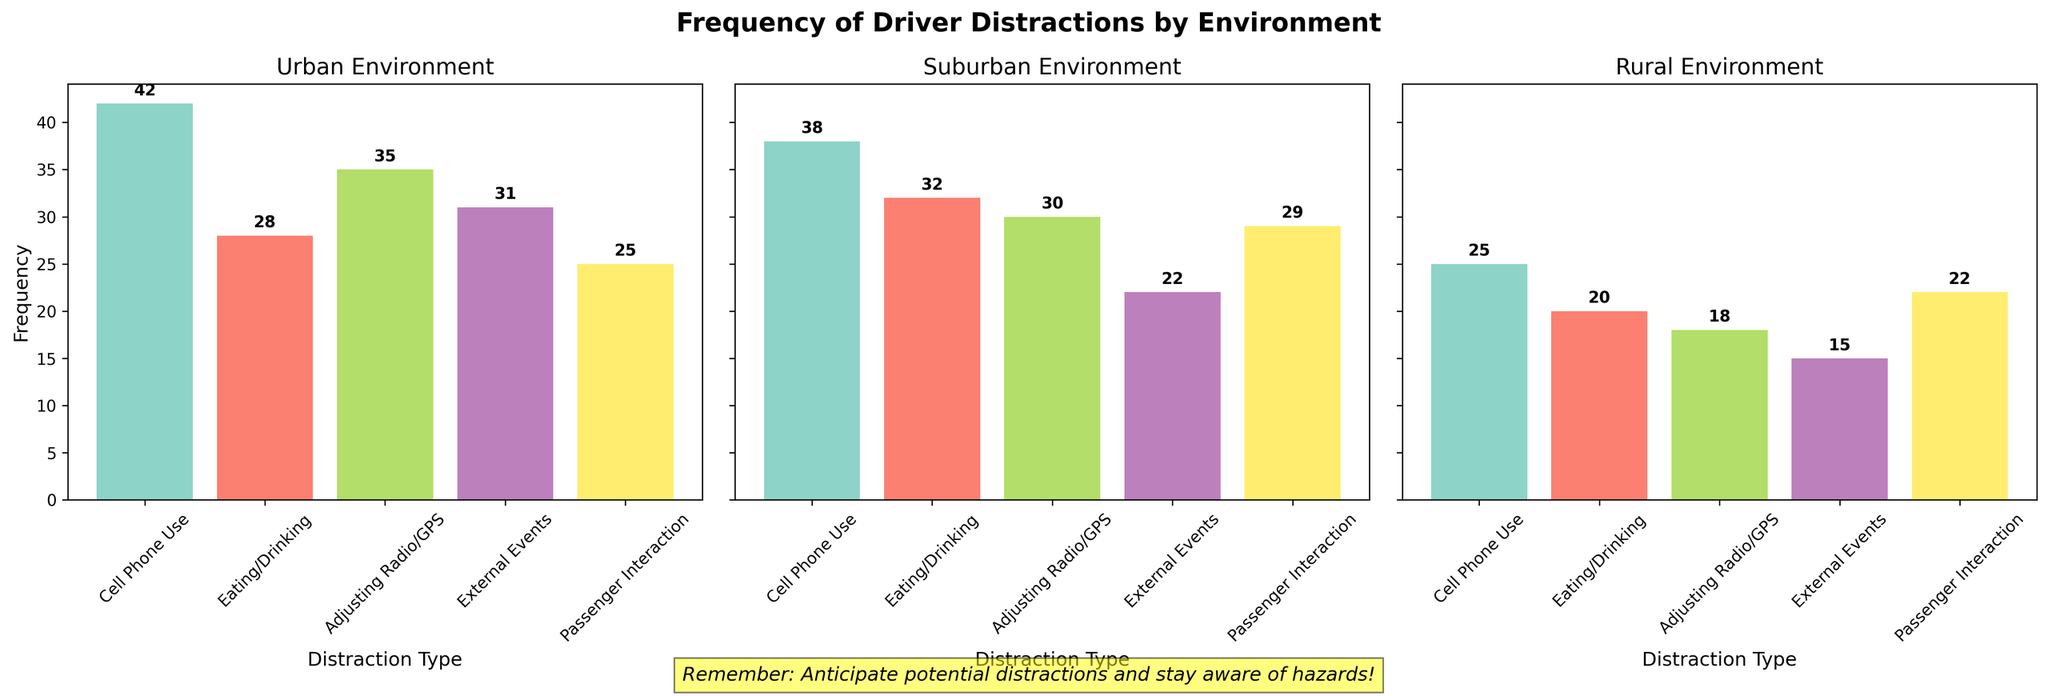What is the total frequency of cell phone use reported by drivers in all environments? Sum the frequencies of cell phone use in Urban, Suburban, and Rural environments (42 + 38 + 25).
Answer: 105 Which environment has the highest frequency of external events distraction? Look at the values for "External Events" in all three environments and identify the one with the highest value (Urban has 31, Suburban has 22, Rural has 15).
Answer: Urban How many more instances of eating/drinking distractions are reported in the Urban environment compared to the Rural environment? Subtract the frequency of eating/drinking in Rural from that in Urban (28 - 20).
Answer: 8 In which environment is adjusting radio/GPS reported most frequently? Compare the frequencies of adjusting radio/GPS in all three environments and note the highest value (Urban has 35, Suburban has 30, Rural has 18).
Answer: Urban What is the average frequency of passenger interaction distractions across all environments? Calculate the average by summing the frequencies of passenger interaction in all environments and dividing by 3 ((25 + 29 + 22) / 3).
Answer: 25.33 Which type of distraction is reported the least in the Rural environment? Identify the distraction type with the lowest frequency in the Rural environment (cell phone use: 25, eating/drinking: 20, adjusting radio/GPS: 18, external events: 15, passenger interaction: 22).
Answer: External Events Comparing cell phone use among all environments, which environment has the lowest frequency? Find the environment with the lowest frequency of cell phone use by comparing values across Urban, Suburban, and Rural (Urban: 42, Suburban: 38, Rural: 25).
Answer: Rural What is the combined frequency of all distractions in the Suburban environment? Sum the frequencies of all distraction types in the Suburban environment (38 + 32 + 30 + 22 + 29).
Answer: 151 Is the frequency of adjusting radio/GPS distractions higher in the Suburban or Rural environment? Compare the frequencies of adjusting radio/GPS in Suburban (30) and Rural (18).
Answer: Suburban 